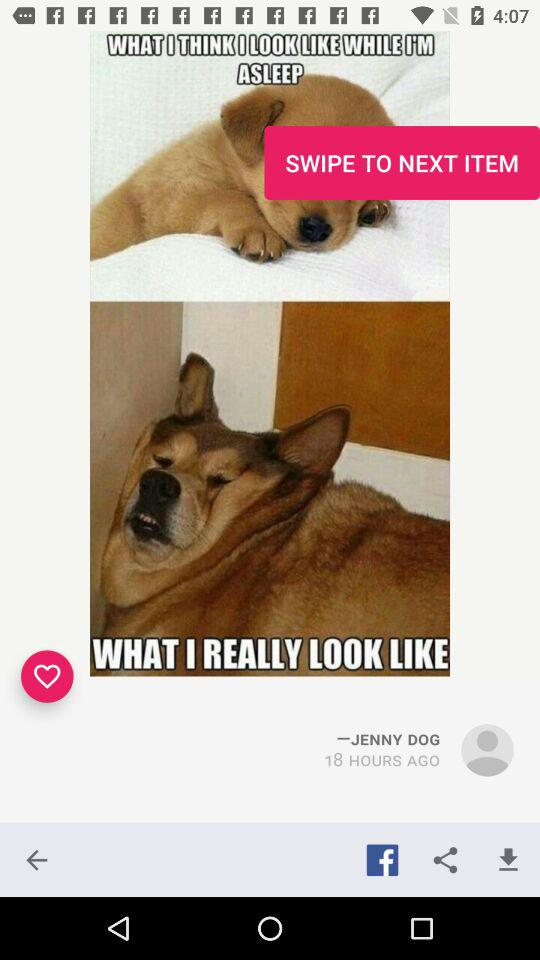How many hours ago was this picture published? This picture was published 18 hours ago. 